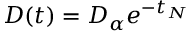<formula> <loc_0><loc_0><loc_500><loc_500>D ( t ) = D _ { \alpha } e ^ { - t _ { N } }</formula> 